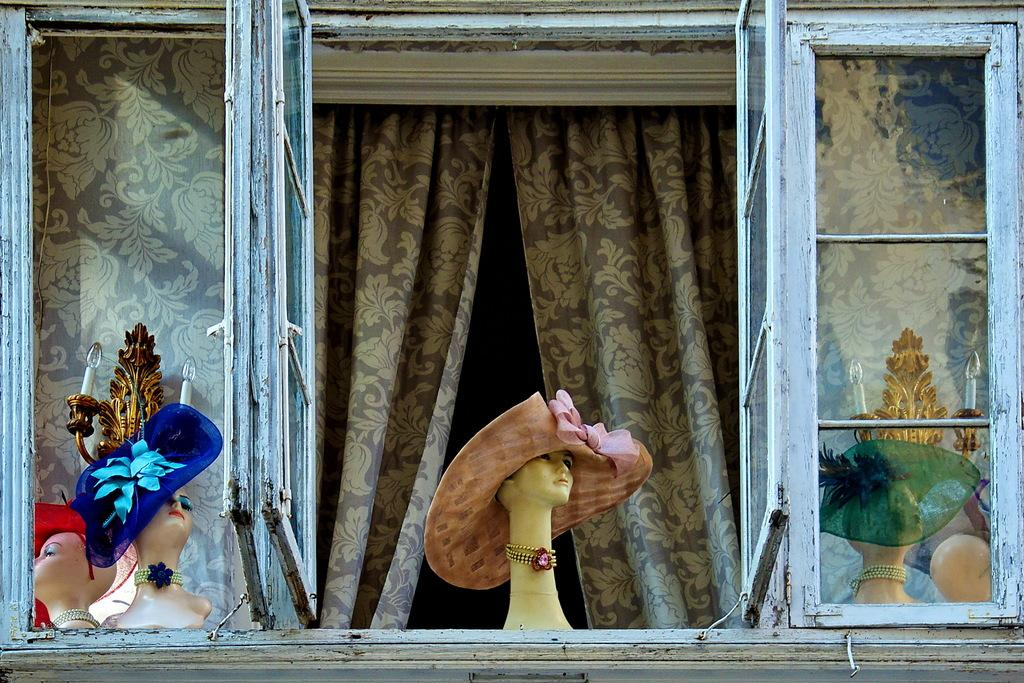What type of figures can be seen in the image? There are mannequins in the image. What accessories are visible in the image? There are caps in the image. What type of illumination is present in the image? There are lights in the image. What type of window treatment is present in the image? There are curtains in the image. What type of structural elements are present in the image? There are metal rods in the image. What type of toothpaste is being used to clean the mannequins in the image? There is no toothpaste present in the image, and the mannequins are not being cleaned. Can you see any tombstones or graves in the image? There is no cemetery or any related elements present in the image. 